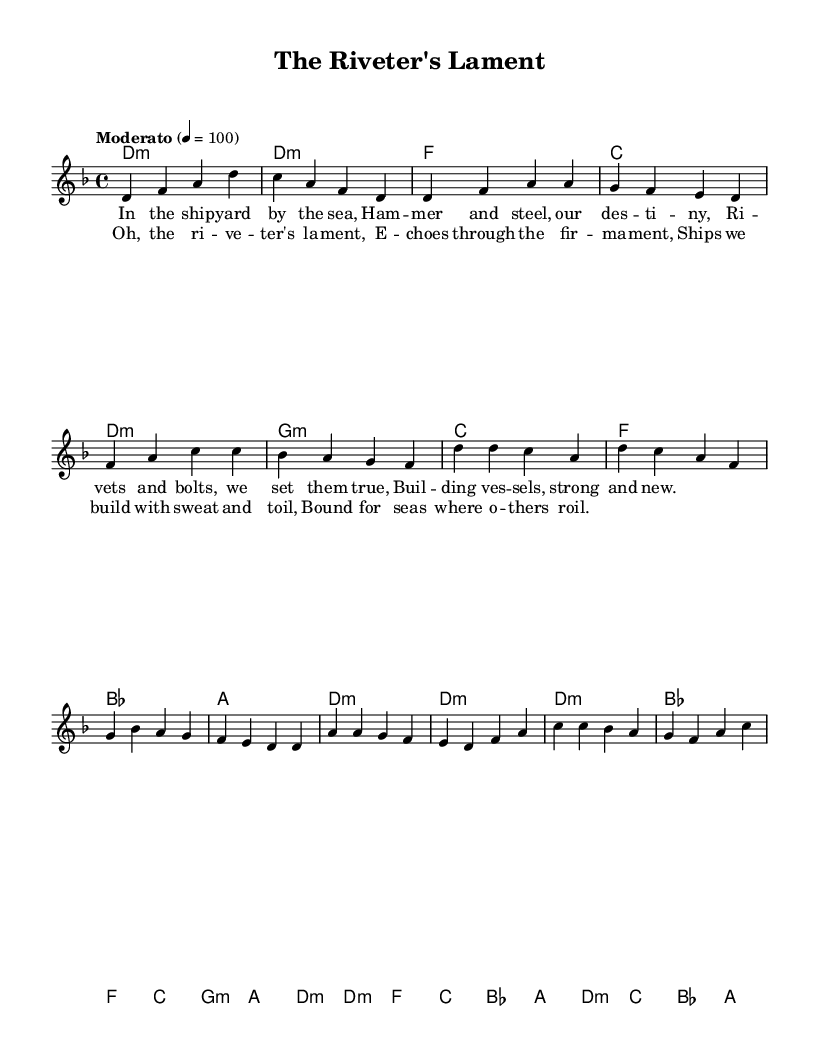What is the key signature of this music? The key signature indicates D minor, which contains one flat (B flat). This is confirmed by the initial key signature marked at the beginning of the score.
Answer: D minor What is the time signature of this piece? The time signature is 4/4, which specifies that there are four quarter note beats in each measure. This is indicated at the beginning of the score.
Answer: 4/4 What is the tempo marking for this piece? The tempo marking is "Moderato," which indicates a moderate pace. The numerical value, 4 = 100, specifies the beats per minute. This information is provided above the staff.
Answer: Moderato How many measures are in the "Chorus" section? The chorus consists of four measures, as indicated by the grouping of the notes presented in that section. A count of the measures confirms that there are exactly four.
Answer: 4 What is the primary theme of the lyrics in the verse? The primary theme revolves around the shipbuilding process, mentioning tools and materials like "rivet" and "steel." The lyrics depict the labor and hope of workers involved in building the ships.
Answer: Shipbuilding What chords are used in the Chorus section? The chords used in the Chorus are D minor, B flat, F, C, G minor, and A. These chords are listed under the 'harmonies' section and match the harmonic structure accompanying the melody.
Answer: D minor, B flat, F, C, G minor, A How does the Chorus relate to the overall theme of labor in maritime work? The Chorus emphasizes the feelings of toil and dedication experienced by the laborers, encapsulated in the phrase "Oh, the riveter's lament." This reflects the struggles and emotional weight of maritime labor in the larger context of folk themes.
Answer: Labor struggles 